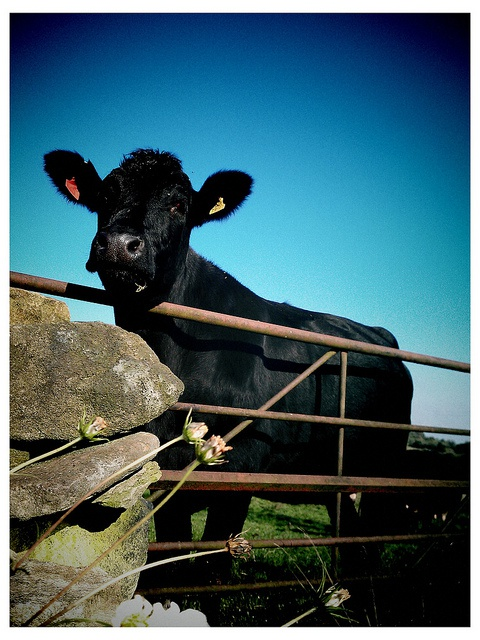Describe the objects in this image and their specific colors. I can see cow in white, black, gray, olive, and tan tones and cow in white, black, and gray tones in this image. 